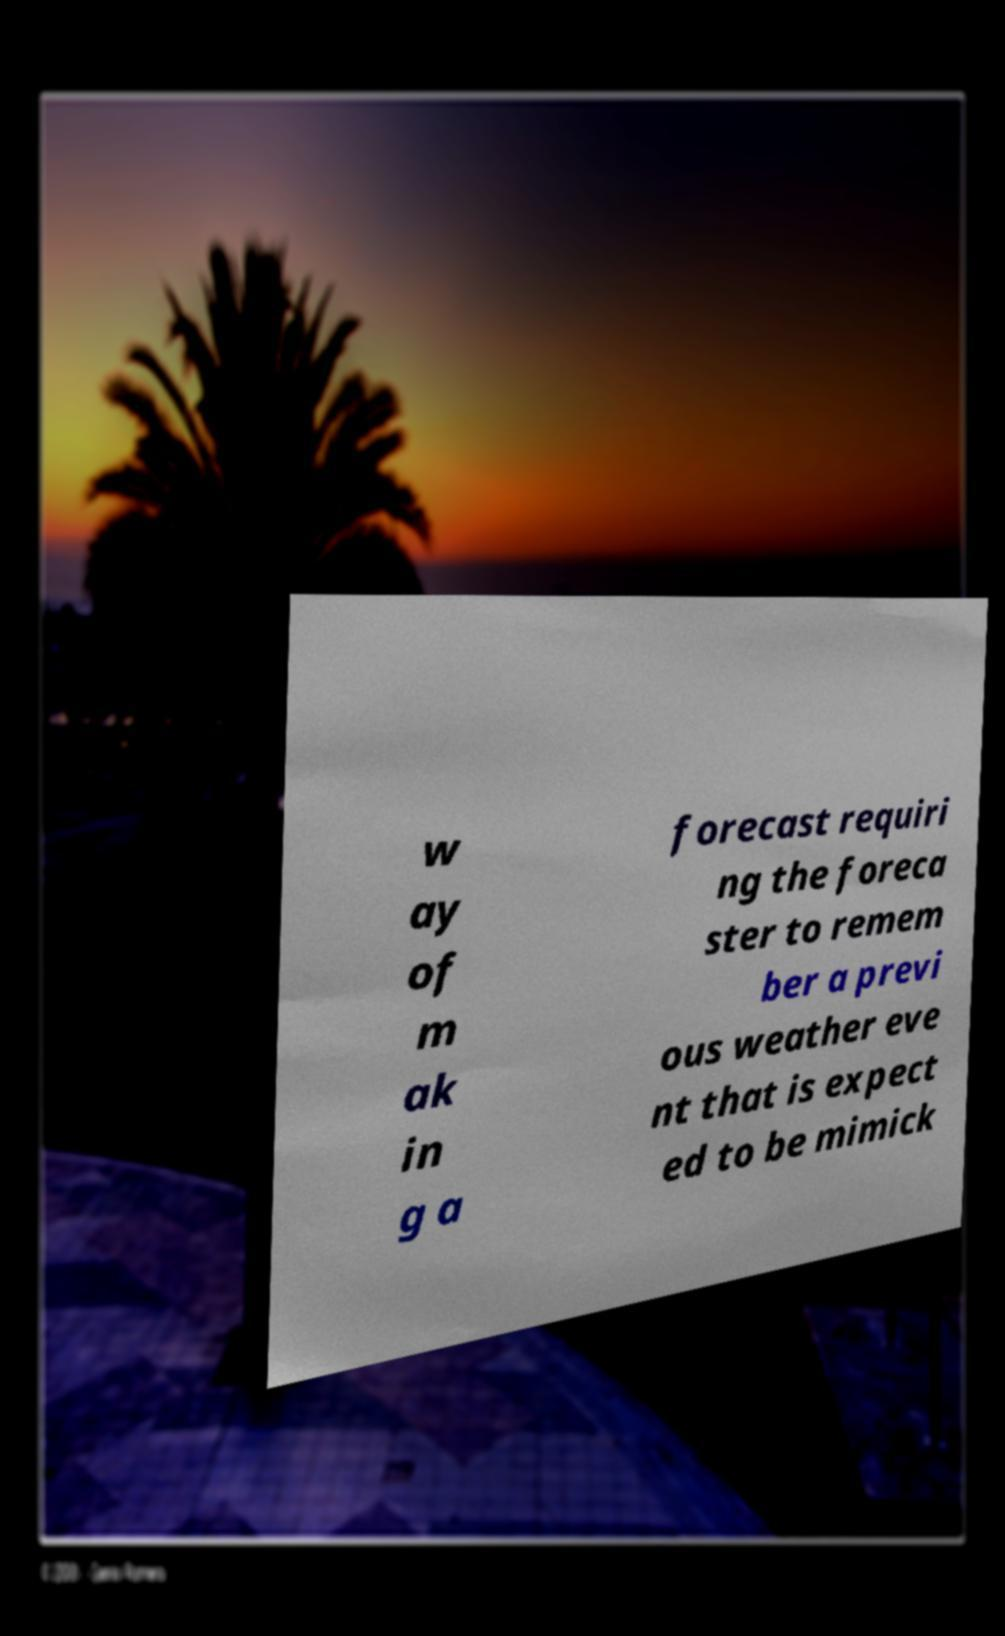For documentation purposes, I need the text within this image transcribed. Could you provide that? w ay of m ak in g a forecast requiri ng the foreca ster to remem ber a previ ous weather eve nt that is expect ed to be mimick 